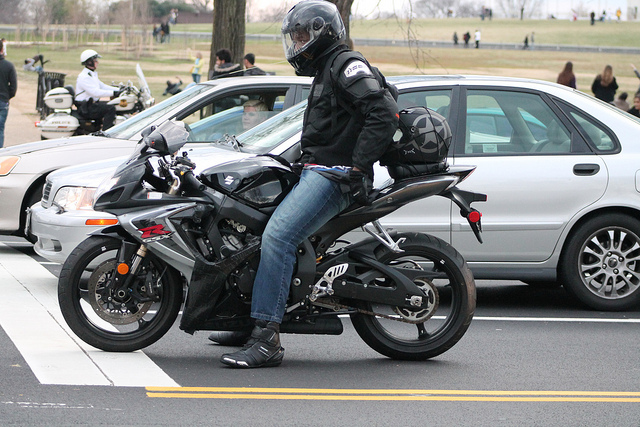Identify the text displayed in this image. R 